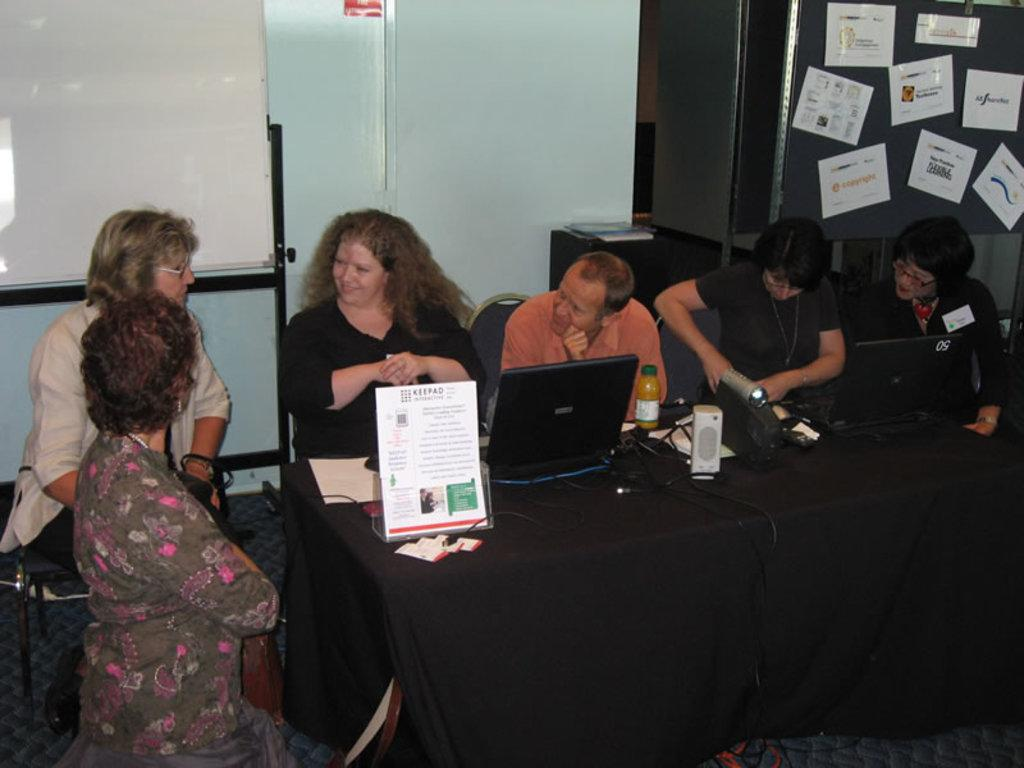What type of structure can be seen in the image? There is a wall in the image. What piece of furniture is present in the image? There is an almirah in the image. What are the people in the image doing? They are sitting on chairs in the image. What other piece of furniture is visible in the image? There is a table in the image. What is placed on the table in the image? There is a poster and a laptop on the table. How many cushions are visible on the chairs in the image? There is no mention of cushions on the chairs in the image; only chairs are mentioned. What type of liquid is being poured from the laptop in the image? There is no liquid present in the image, as it features a laptop and a poster on a table. 